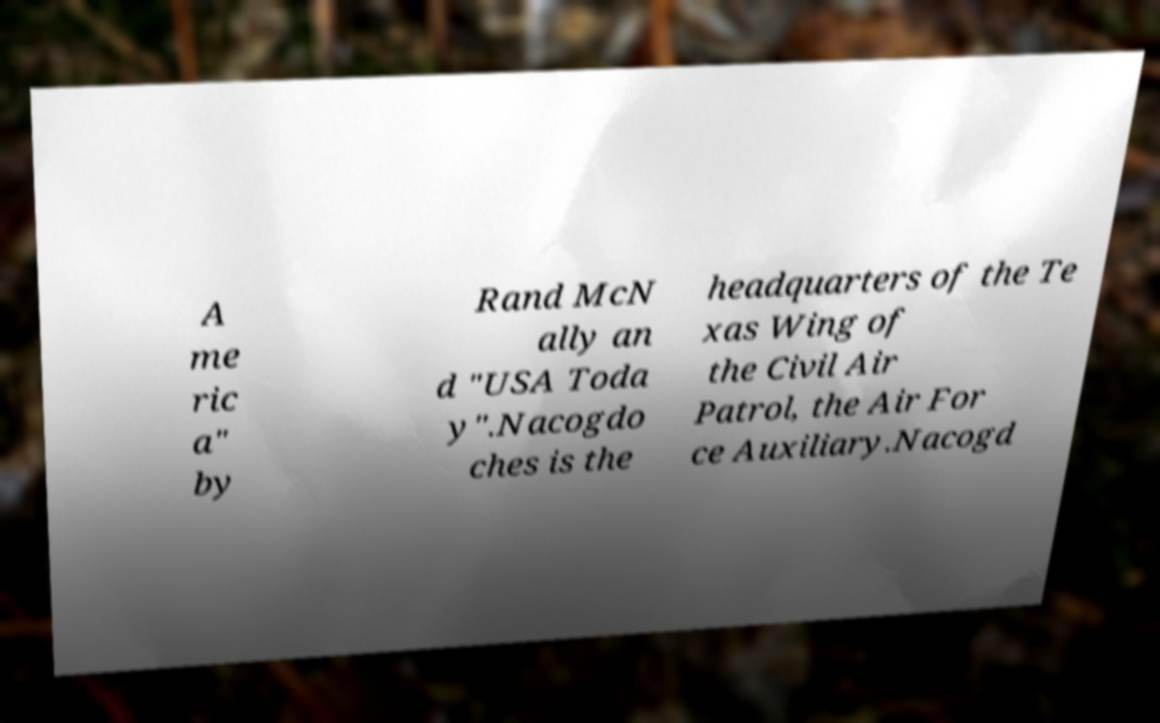I need the written content from this picture converted into text. Can you do that? A me ric a" by Rand McN ally an d "USA Toda y".Nacogdo ches is the headquarters of the Te xas Wing of the Civil Air Patrol, the Air For ce Auxiliary.Nacogd 